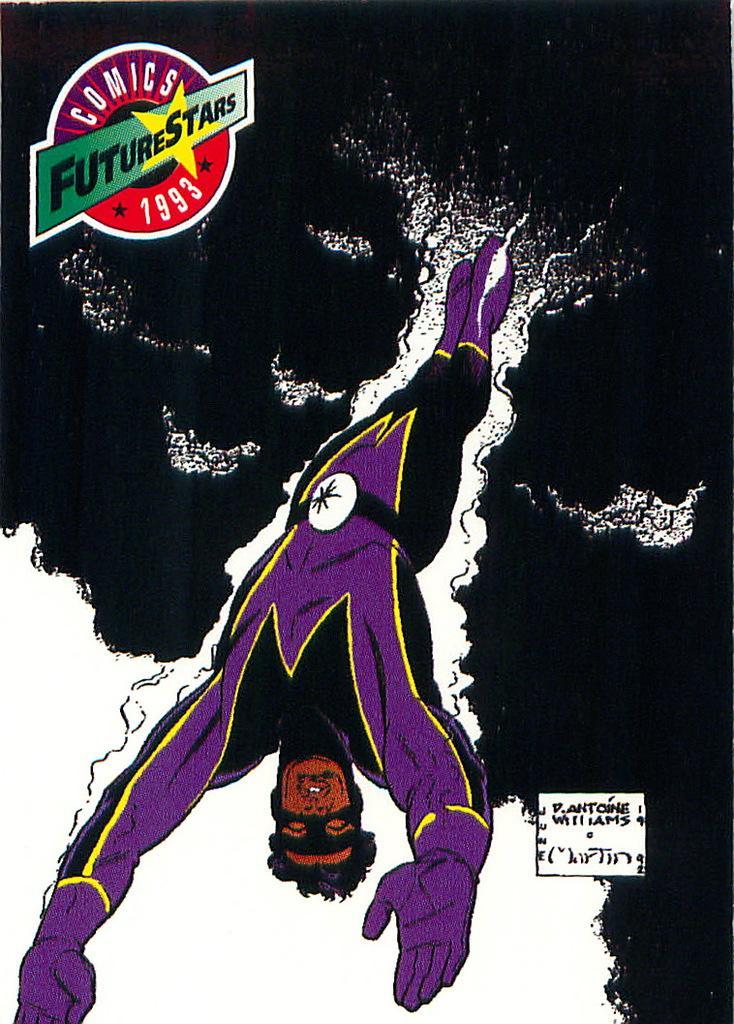Please provide a concise description of this image. In this picture there is a poster of a future star in the image. 